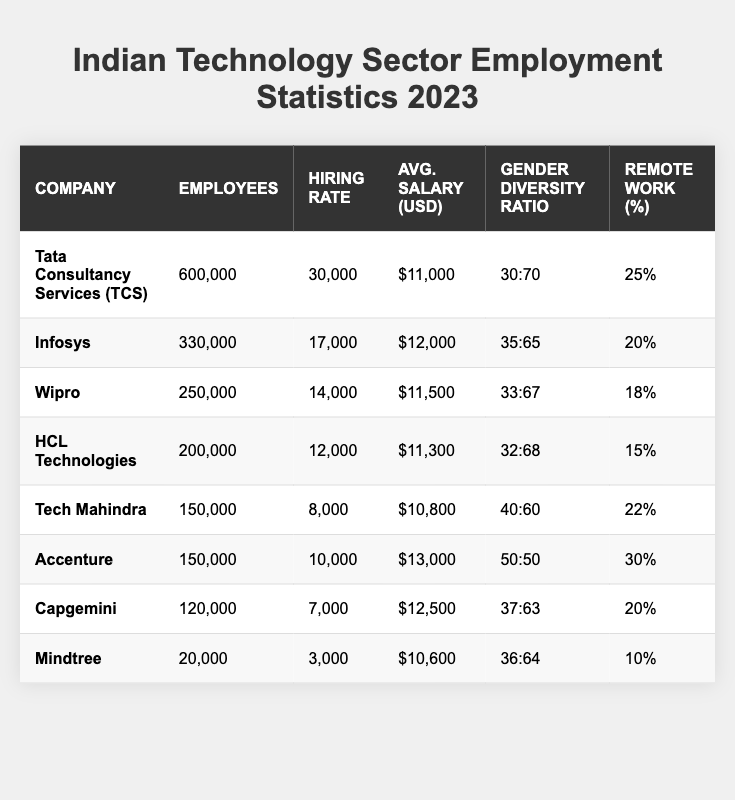What is the highest average salary among the companies listed? By reviewing the average salary values, Accenture has the highest salary at $13,000.
Answer: $13,000 Which company has the lowest number of employees? Mindtree has the lowest employee count with 20,000.
Answer: 20,000 What is the hiring rate of Wipro? Wipro has a hiring rate of 14,000.
Answer: 14,000 Which company has the largest percentage of remote work? Accenture, with 30%, has the largest percentage of remote work.
Answer: 30% Is the gender diversity ratio of Tech Mahindra 40:60? Yes, Tech Mahindra has a gender diversity ratio of 40:60 as shown in the table.
Answer: Yes What is the total number of employees for TCS and Infosys combined? The total is calculated by adding TCS (600,000) and Infosys (330,000), resulting in 930,000.
Answer: 930,000 Which company has the highest hiring rate among those listed? TCS has the highest hiring rate at 30,000 employees hired.
Answer: 30,000 If you compare HCL Technologies and Capgemini, which has a higher average salary? HCL Technologies has an average salary of $11,300 and Capgemini $12,500. Since $12,500 > $11,300, Capgemini has a higher salary.
Answer: Capgemini What is the average gender diversity ratio across all companies listed? Adding the ratio proportions calculated from each company's gender diversity and averaging them provides that the overall diversity is roughly 36.8:63.2.
Answer: Approximately 37:63 How many companies have more than 200,000 employees? There are three companies: TCS, Infosys, and Wipro, each with more than 200,000 employees.
Answer: 3 